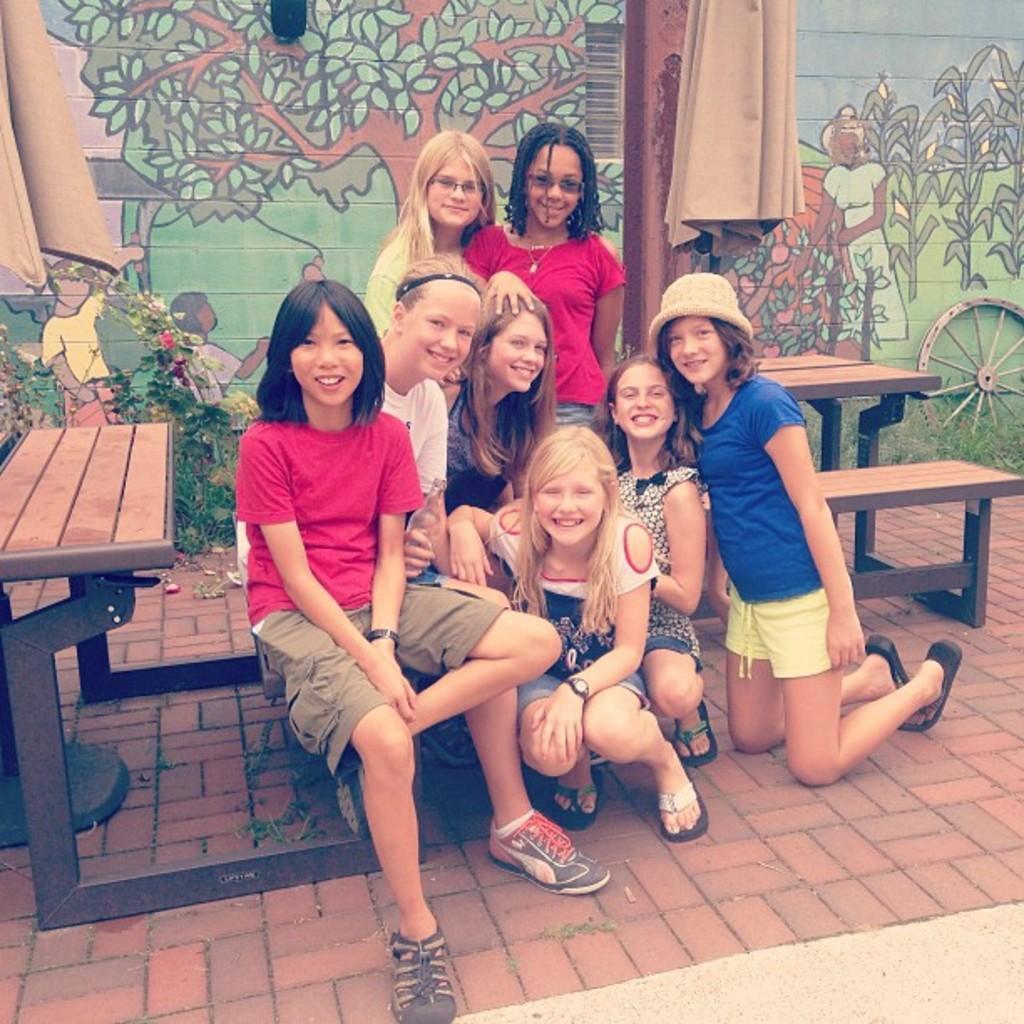Describe this image in one or two sentences. In this image there are a few people sitting on the benches and few are sitting on their knees. In the background there is a painting on the wall, in front of the wall there are plants, grass, pole and a few other objects. 